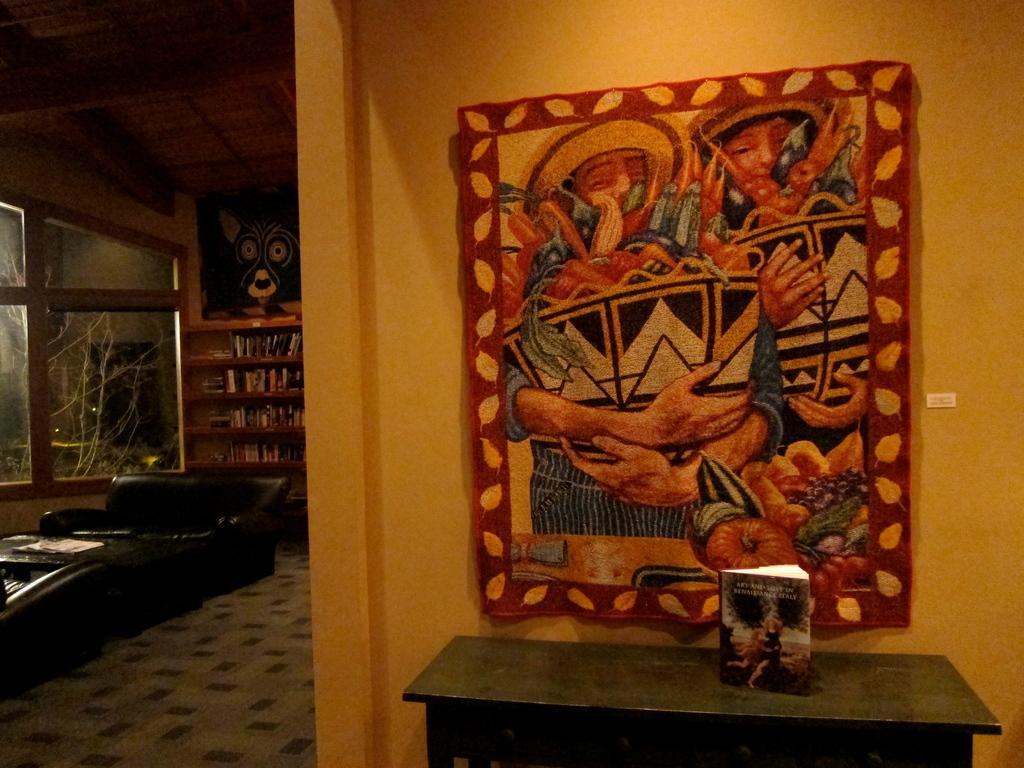Please provide a concise description of this image. This picture shows a room we see a sofa ,a cupboard and a table 